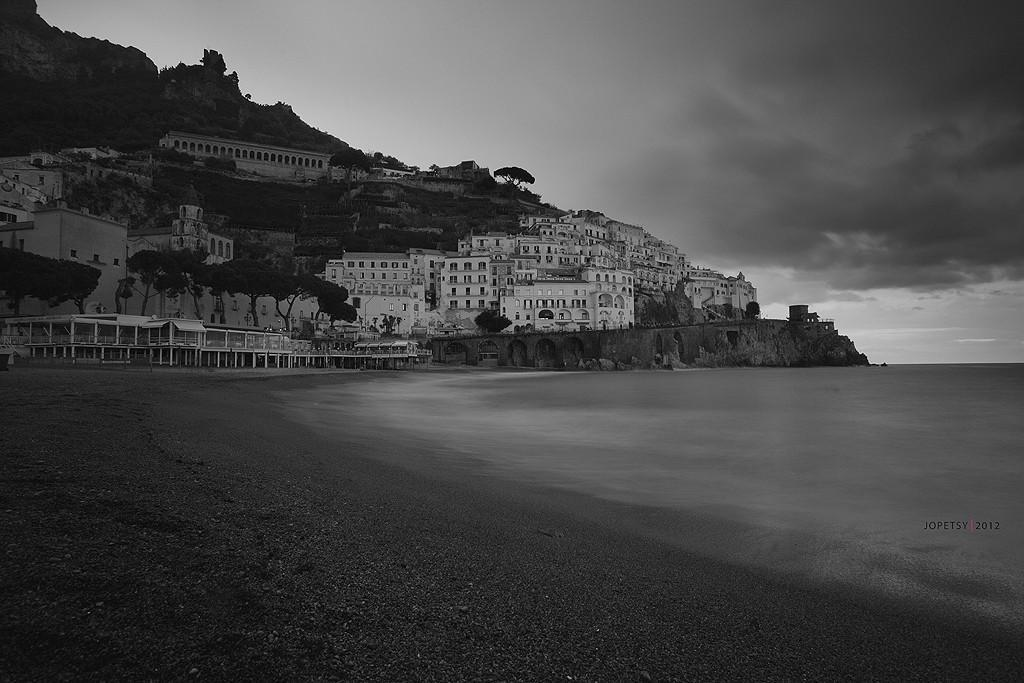What is the color scheme of the image? The image is black and white. What type of structures can be seen in the image? There are buildings in the image. What natural elements are present in the image? There are trees, water, and mountains visible in the image. What is visible in the sky in the image? The sky is visible in the image, and clouds are present. How many geese are swimming in the water in the image? There are no geese present in the image; it features buildings, trees, water, mountains, and a sky with clouds. Is there a goat grazing on the mountains in the image? There is no goat present in the image; it only features buildings, trees, water, mountains, and a sky with clouds. 